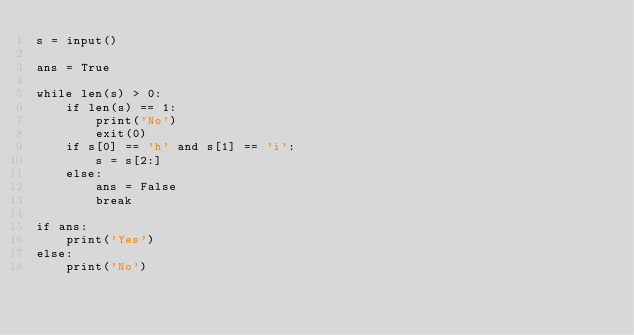Convert code to text. <code><loc_0><loc_0><loc_500><loc_500><_Python_>s = input()

ans = True

while len(s) > 0:
    if len(s) == 1:
        print('No')
        exit(0)
    if s[0] == 'h' and s[1] == 'i':
        s = s[2:]
    else:
        ans = False
        break

if ans:
    print('Yes')
else:
    print('No')</code> 